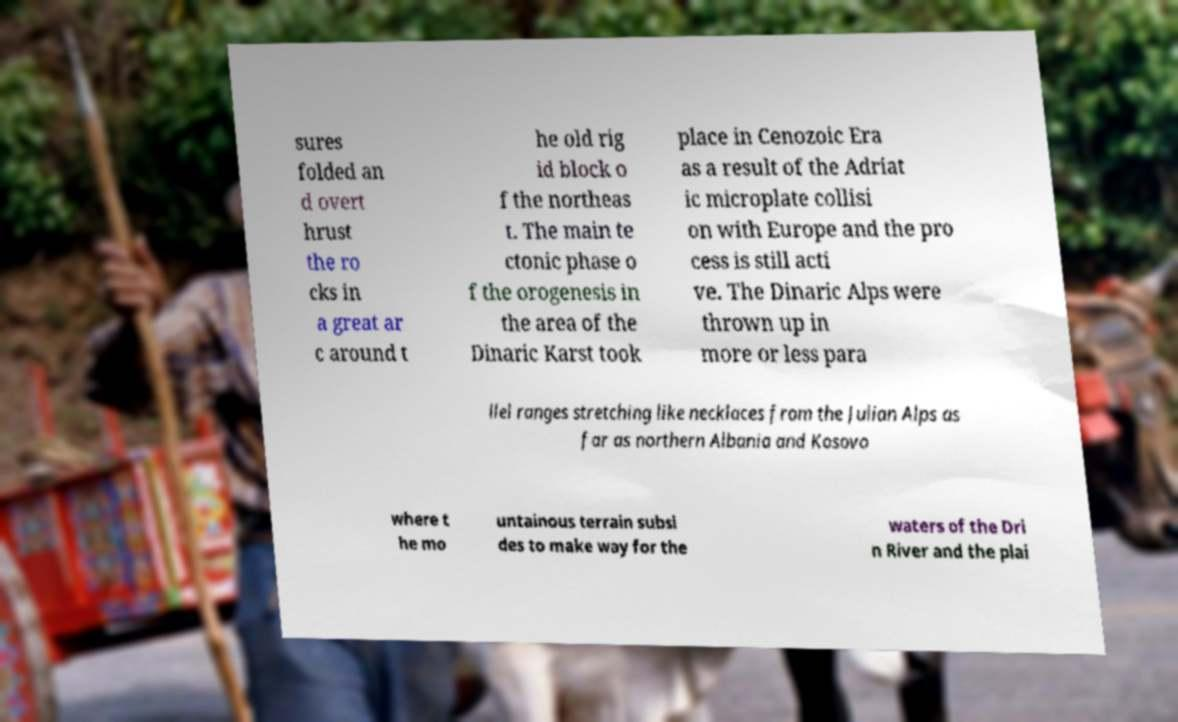For documentation purposes, I need the text within this image transcribed. Could you provide that? sures folded an d overt hrust the ro cks in a great ar c around t he old rig id block o f the northeas t. The main te ctonic phase o f the orogenesis in the area of the Dinaric Karst took place in Cenozoic Era as a result of the Adriat ic microplate collisi on with Europe and the pro cess is still acti ve. The Dinaric Alps were thrown up in more or less para llel ranges stretching like necklaces from the Julian Alps as far as northern Albania and Kosovo where t he mo untainous terrain subsi des to make way for the waters of the Dri n River and the plai 